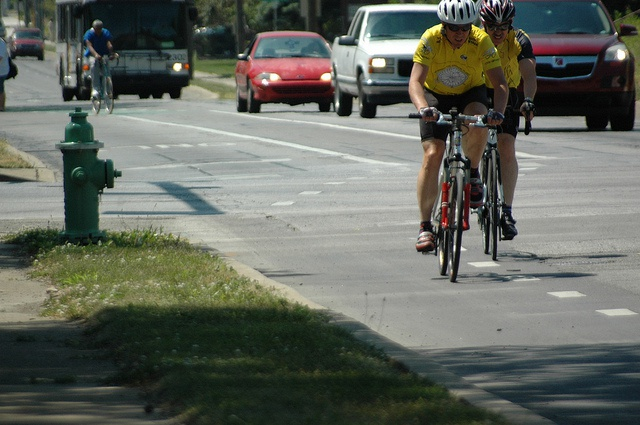Describe the objects in this image and their specific colors. I can see people in black, olive, maroon, and gray tones, car in black, blue, darkblue, and gray tones, bus in black, gray, purple, and darkgray tones, truck in black, white, gray, and darkgray tones, and car in black, gray, salmon, and brown tones in this image. 